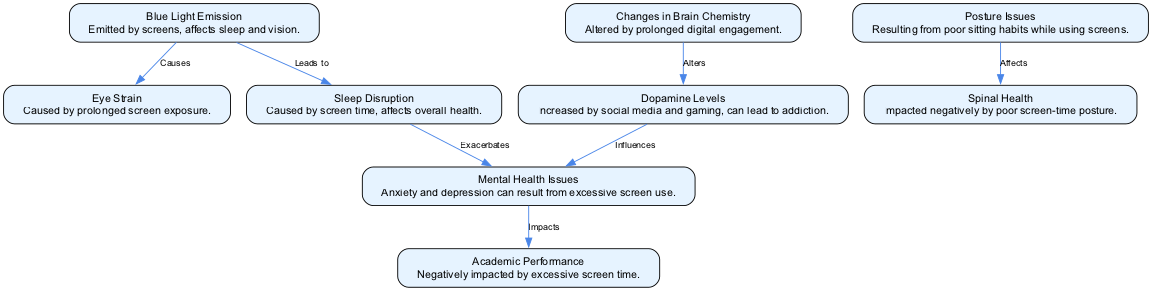What's the total number of nodes in the diagram? The diagram contains a list of nodes that can be counted: eye strain, blue light, posture issues, spinal health, brain chemistry, dopamine levels, sleep disruption, mental health, and academic performance. This sums up to a total of 9 nodes.
Answer: 9 What relationship does blue light have with eye strain? The diagram shows a directed edge from blue light to eye strain labeled "Causes," indicating that blue light is a cause of eye strain.
Answer: Causes Which condition is negatively impacted by poor screen-time posture? According to the diagram, the node connected to posture issues via an edge labeled "Affects" is spinal health, indicating that spinal health is impacted negatively by poor posture.
Answer: Spinal Health How do dopamine levels influence mental health according to the diagram? The diagram illustrates a directed connection from dopamine levels to mental health, labeled "Influences." This indicates that alterations in dopamine levels can have an effect on mental health.
Answer: Influences What are the consequences of sleep disruption as indicated in the diagram? The diagram shows that sleep disruption has a direct effect on mental health, as illustrated by the edge labeled "Exacerbates" leading from sleep disruption to mental health. This means sleep disruption worsens mental health issues.
Answer: Exacerbates How many edges are there in the diagram? By counting the directed connections (edges) between nodes, we find the following edges: blue light to eye strain, blue light to sleep disruption, posture issues to spinal health, brain chemistry to dopamine levels, dopamine levels to mental health, sleep disruption to mental health, and mental health to academic performance, totaling 7 edges.
Answer: 7 What impact does excessive screen time have on academic performance? The diagram shows a directed edge from mental health to academic performance labeled "Impacts," indicating that poor mental health resulting from excessive screen time can negatively affect academic performance.
Answer: Impacts 